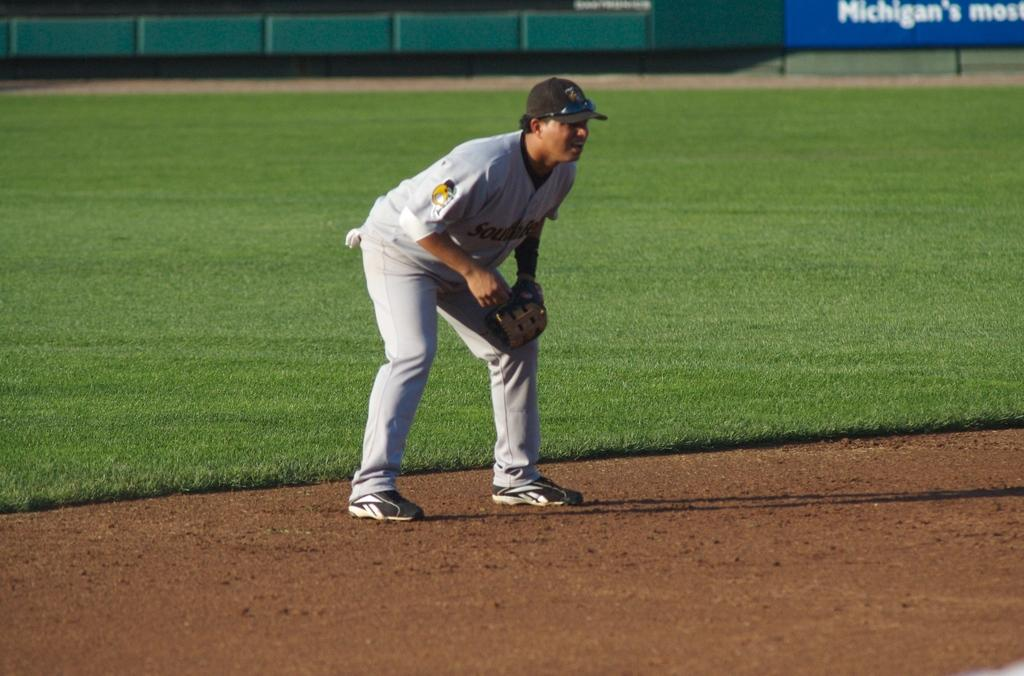<image>
Offer a succinct explanation of the picture presented. A baseball player is ready on a field in Michigan. 